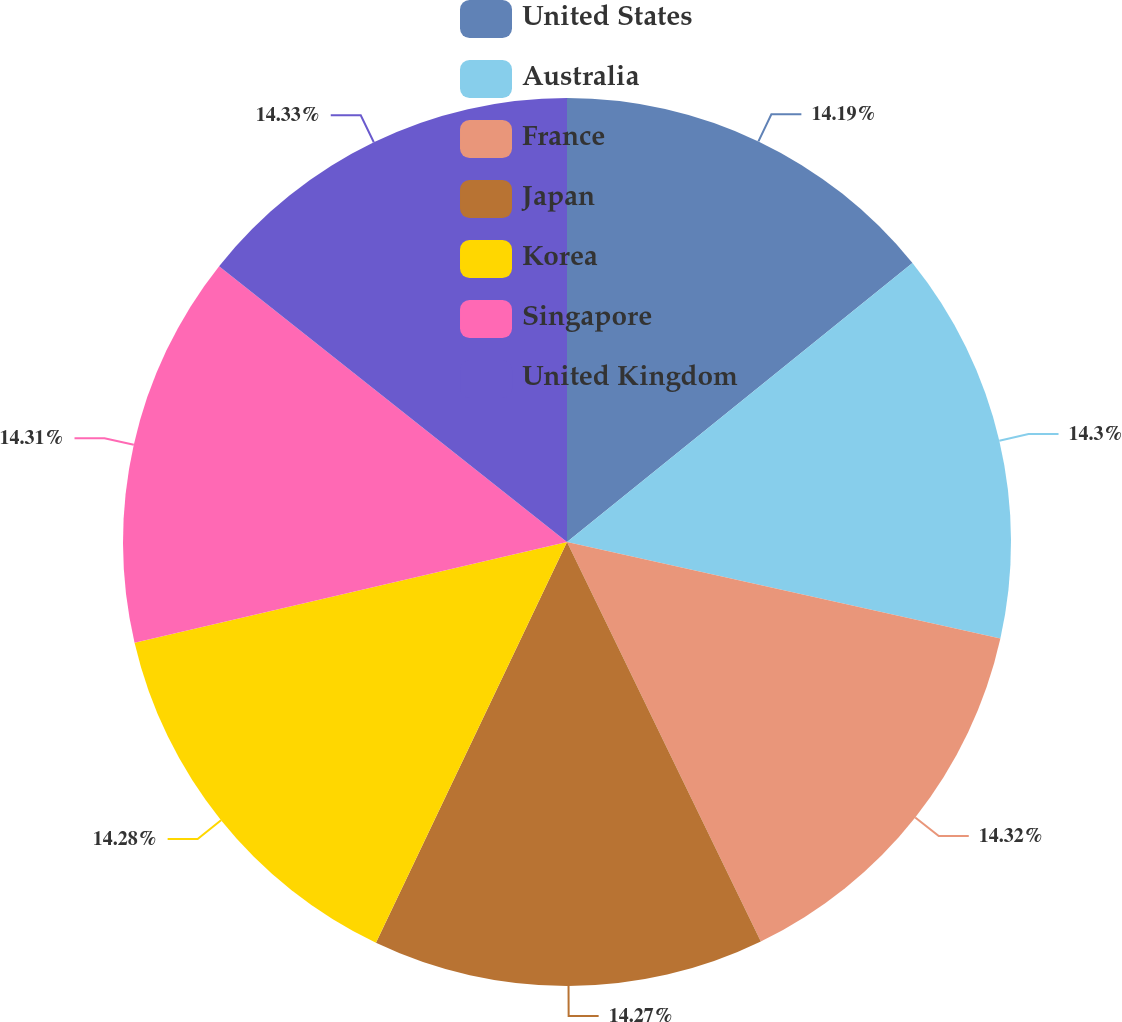<chart> <loc_0><loc_0><loc_500><loc_500><pie_chart><fcel>United States<fcel>Australia<fcel>France<fcel>Japan<fcel>Korea<fcel>Singapore<fcel>United Kingdom<nl><fcel>14.19%<fcel>14.3%<fcel>14.32%<fcel>14.27%<fcel>14.28%<fcel>14.31%<fcel>14.33%<nl></chart> 